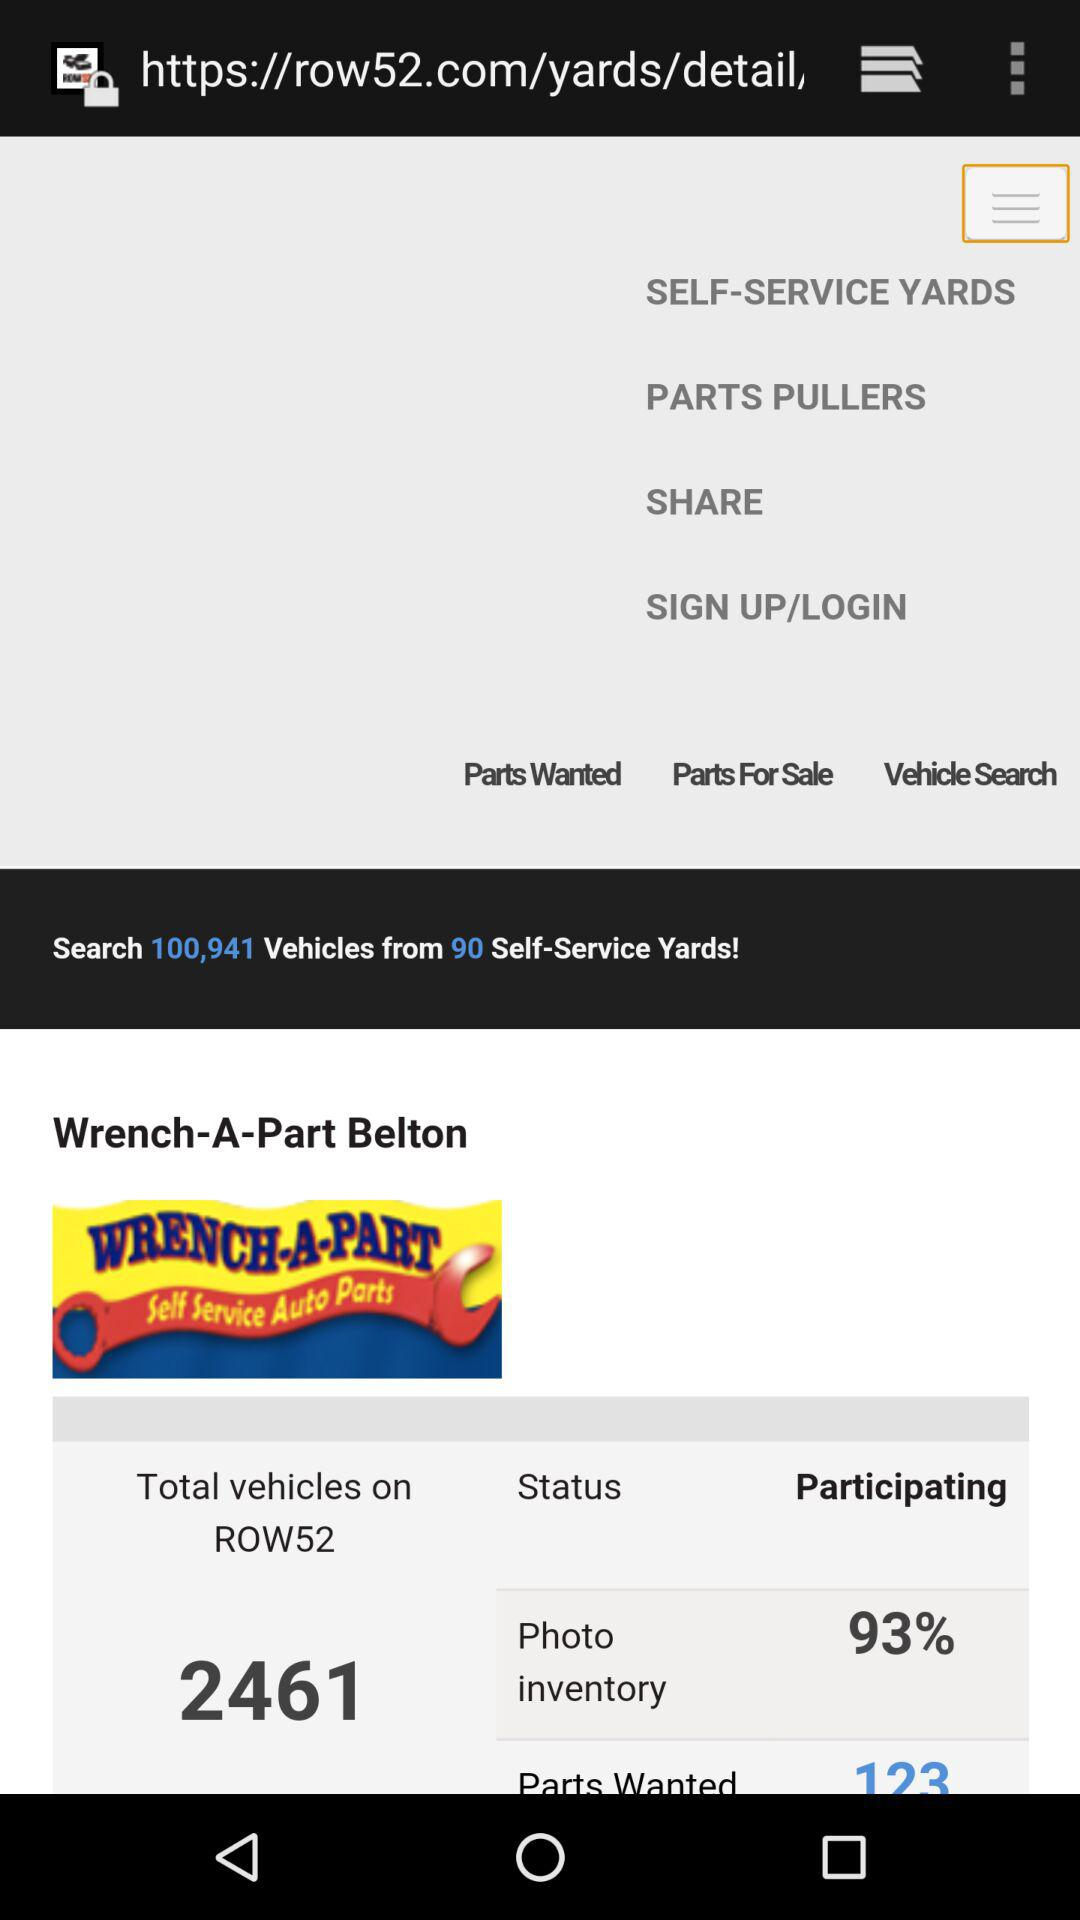What percentage of the yards in the search results are participating in Row52?
Answer the question using a single word or phrase. 93% 